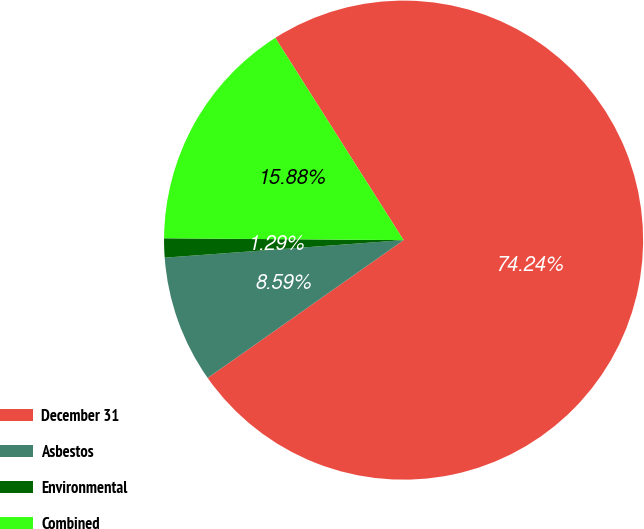Convert chart. <chart><loc_0><loc_0><loc_500><loc_500><pie_chart><fcel>December 31<fcel>Asbestos<fcel>Environmental<fcel>Combined<nl><fcel>74.24%<fcel>8.59%<fcel>1.29%<fcel>15.88%<nl></chart> 